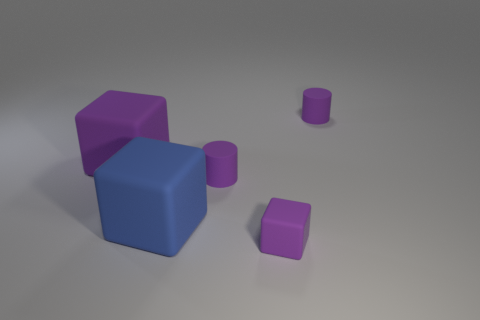Subtract all tiny matte blocks. How many blocks are left? 2 Add 2 blocks. How many objects exist? 7 Subtract all purple cubes. How many cubes are left? 1 Subtract 0 brown cylinders. How many objects are left? 5 Subtract all cylinders. How many objects are left? 3 Subtract 1 cubes. How many cubes are left? 2 Subtract all brown cubes. Subtract all gray spheres. How many cubes are left? 3 Subtract all purple cylinders. How many yellow blocks are left? 0 Subtract all purple things. Subtract all small purple blocks. How many objects are left? 0 Add 3 small cylinders. How many small cylinders are left? 5 